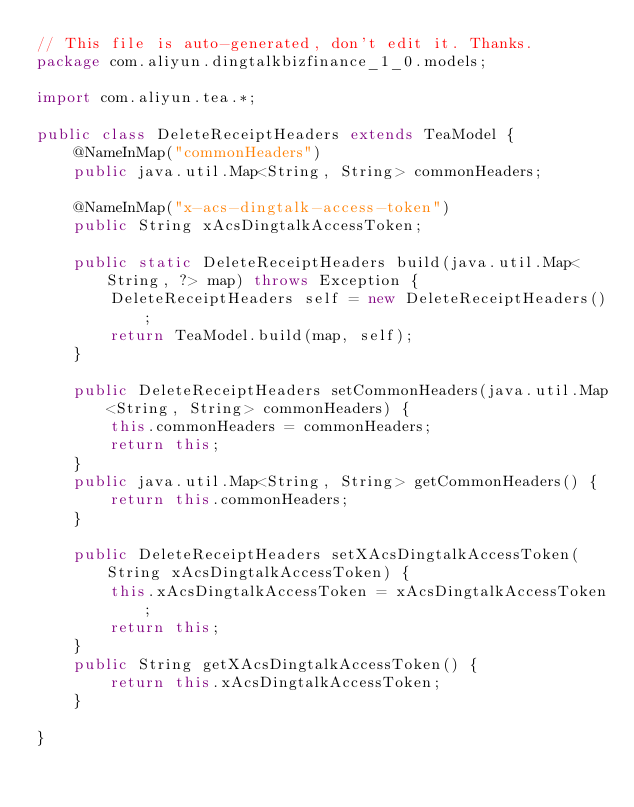Convert code to text. <code><loc_0><loc_0><loc_500><loc_500><_Java_>// This file is auto-generated, don't edit it. Thanks.
package com.aliyun.dingtalkbizfinance_1_0.models;

import com.aliyun.tea.*;

public class DeleteReceiptHeaders extends TeaModel {
    @NameInMap("commonHeaders")
    public java.util.Map<String, String> commonHeaders;

    @NameInMap("x-acs-dingtalk-access-token")
    public String xAcsDingtalkAccessToken;

    public static DeleteReceiptHeaders build(java.util.Map<String, ?> map) throws Exception {
        DeleteReceiptHeaders self = new DeleteReceiptHeaders();
        return TeaModel.build(map, self);
    }

    public DeleteReceiptHeaders setCommonHeaders(java.util.Map<String, String> commonHeaders) {
        this.commonHeaders = commonHeaders;
        return this;
    }
    public java.util.Map<String, String> getCommonHeaders() {
        return this.commonHeaders;
    }

    public DeleteReceiptHeaders setXAcsDingtalkAccessToken(String xAcsDingtalkAccessToken) {
        this.xAcsDingtalkAccessToken = xAcsDingtalkAccessToken;
        return this;
    }
    public String getXAcsDingtalkAccessToken() {
        return this.xAcsDingtalkAccessToken;
    }

}
</code> 